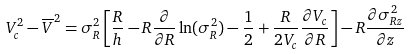Convert formula to latex. <formula><loc_0><loc_0><loc_500><loc_500>V _ { c } ^ { 2 } - \overline { V } ^ { 2 } = \sigma _ { R } ^ { 2 } \left [ \frac { R } { h } - R \frac { \partial } { \partial R } \ln ( \sigma _ { R } ^ { 2 } ) - \frac { 1 } { 2 } + \frac { R } { 2 V _ { c } } \frac { \partial V _ { c } } { \partial R } \right ] - R \frac { \partial \sigma ^ { 2 } _ { R z } } { \partial z }</formula> 